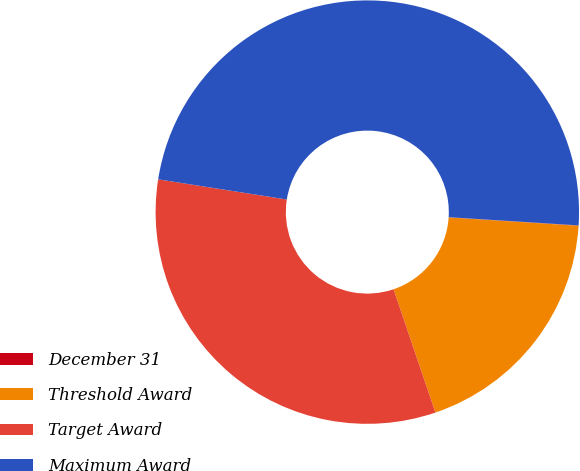<chart> <loc_0><loc_0><loc_500><loc_500><pie_chart><fcel>December 31<fcel>Threshold Award<fcel>Target Award<fcel>Maximum Award<nl><fcel>0.03%<fcel>18.76%<fcel>32.69%<fcel>48.53%<nl></chart> 